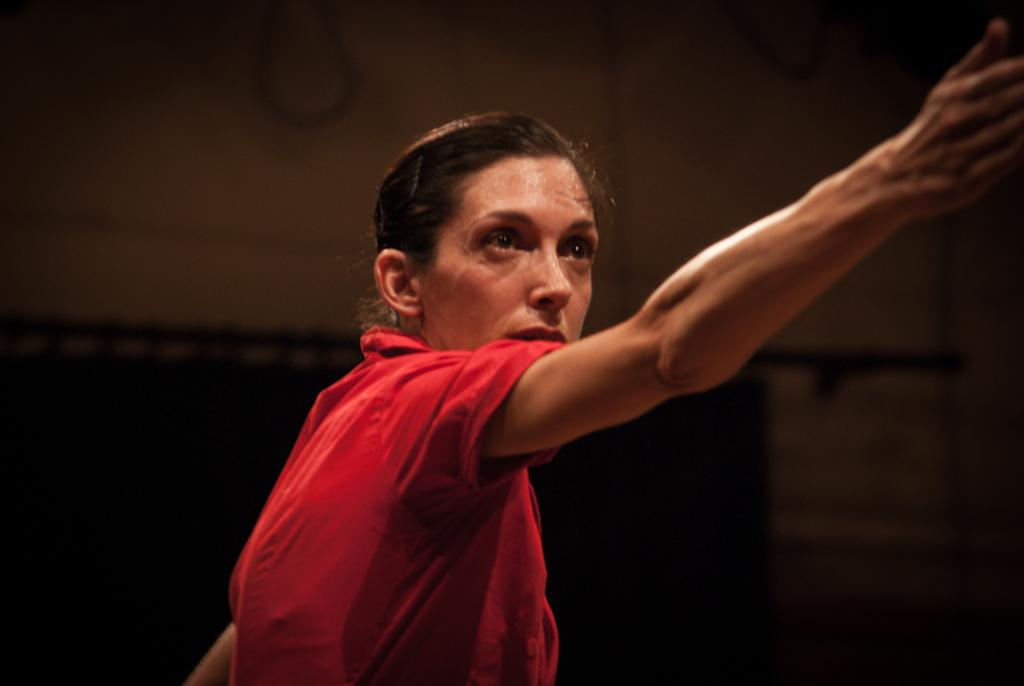What is the color of the woman's dress in the image? The woman is wearing a red dress in the image. What is the woman doing in the image? The woman is stretching her hand in the image. How would you describe the background of the image? The background of the image is dark. How many badges can be seen on the woman's dress in the image? There are no badges visible on the woman's dress in the image. What type of cream is being used by the woman in the image? There is no cream present in the image. 